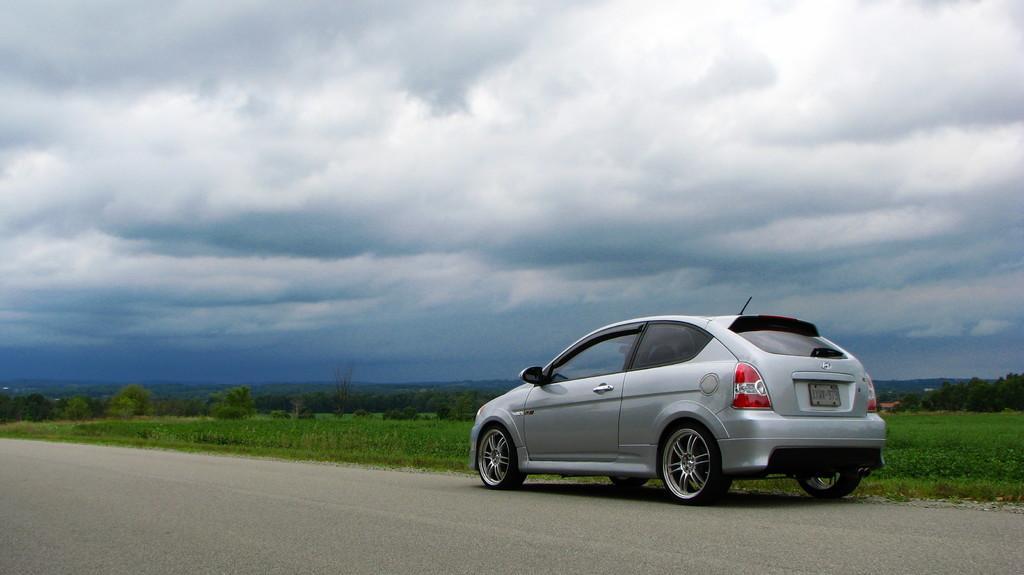Please provide a concise description of this image. In this image I can see a car. There are plants, trees, there is grass and in the background there is sky. 